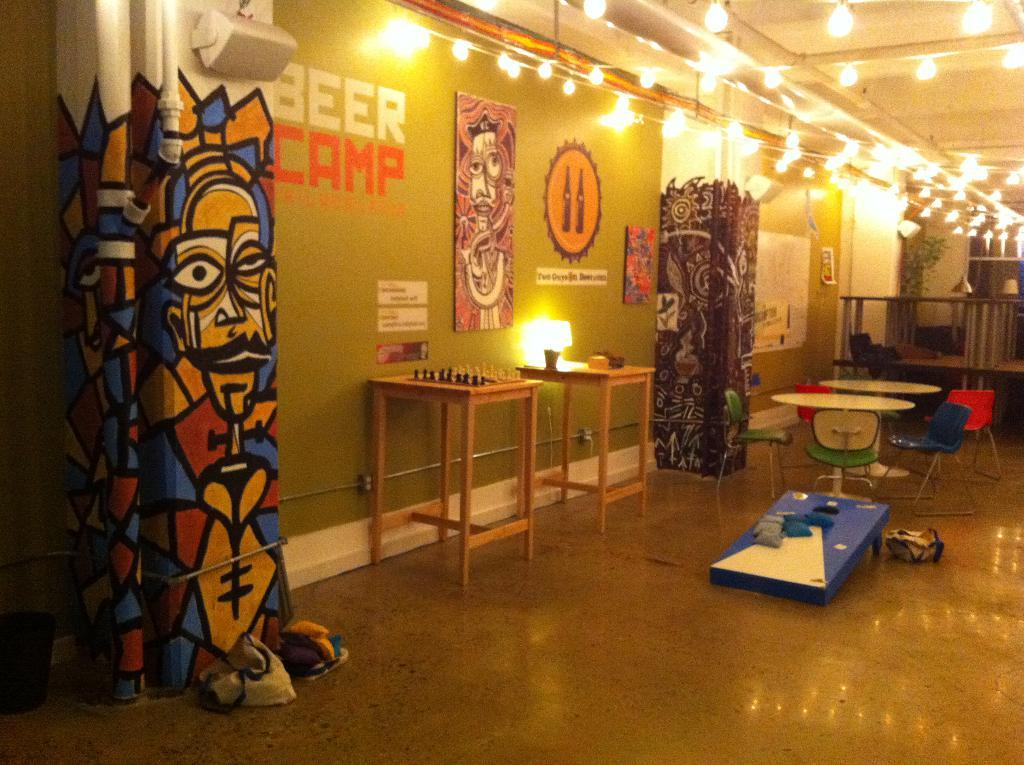<image>
Render a clear and concise summary of the photo. A green walled room with chess tables and curtains at the Beer Camp. 